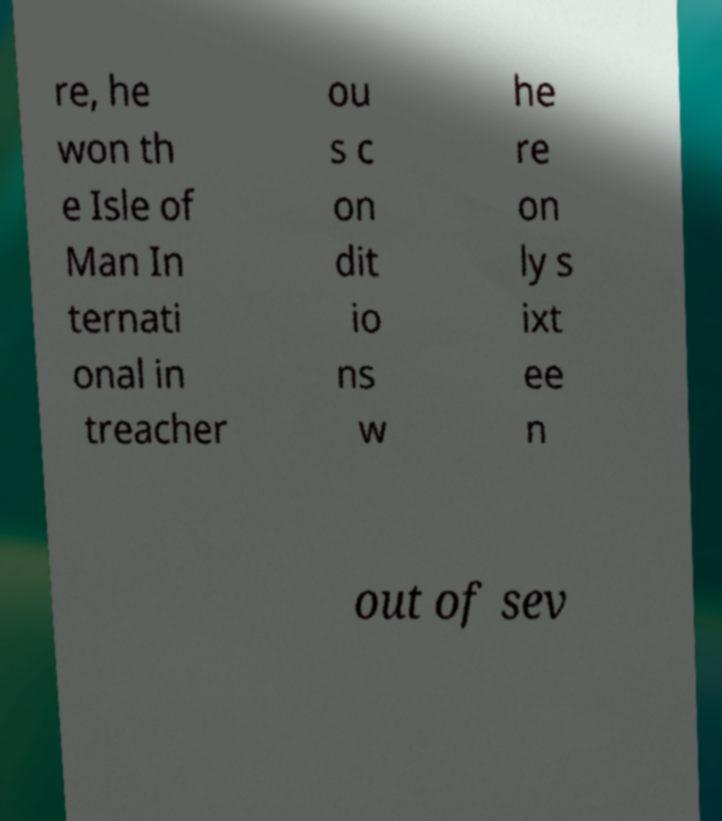Please identify and transcribe the text found in this image. re, he won th e Isle of Man In ternati onal in treacher ou s c on dit io ns w he re on ly s ixt ee n out of sev 